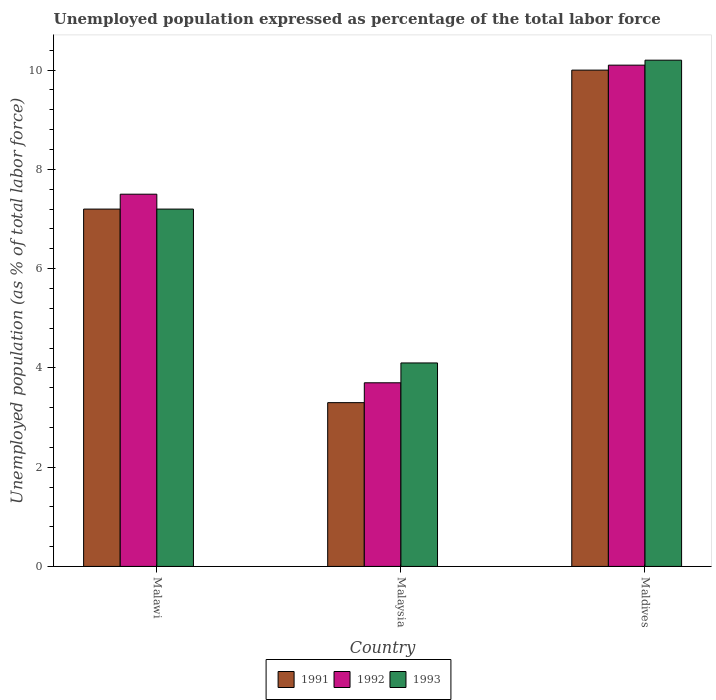How many different coloured bars are there?
Offer a terse response. 3. How many groups of bars are there?
Offer a very short reply. 3. Are the number of bars per tick equal to the number of legend labels?
Keep it short and to the point. Yes. Are the number of bars on each tick of the X-axis equal?
Your answer should be very brief. Yes. How many bars are there on the 2nd tick from the left?
Offer a very short reply. 3. How many bars are there on the 2nd tick from the right?
Your answer should be compact. 3. What is the label of the 3rd group of bars from the left?
Provide a short and direct response. Maldives. In how many cases, is the number of bars for a given country not equal to the number of legend labels?
Your answer should be compact. 0. What is the unemployment in in 1993 in Maldives?
Your answer should be very brief. 10.2. Across all countries, what is the maximum unemployment in in 1991?
Offer a terse response. 10. Across all countries, what is the minimum unemployment in in 1991?
Offer a terse response. 3.3. In which country was the unemployment in in 1992 maximum?
Ensure brevity in your answer.  Maldives. In which country was the unemployment in in 1993 minimum?
Your response must be concise. Malaysia. What is the total unemployment in in 1991 in the graph?
Offer a terse response. 20.5. What is the difference between the unemployment in in 1992 in Malawi and that in Malaysia?
Give a very brief answer. 3.8. What is the difference between the unemployment in in 1991 in Malaysia and the unemployment in in 1993 in Malawi?
Provide a short and direct response. -3.9. What is the average unemployment in in 1991 per country?
Offer a terse response. 6.83. What is the ratio of the unemployment in in 1991 in Malawi to that in Maldives?
Your answer should be compact. 0.72. Is the unemployment in in 1991 in Malawi less than that in Malaysia?
Your answer should be compact. No. Is the difference between the unemployment in in 1993 in Malawi and Malaysia greater than the difference between the unemployment in in 1991 in Malawi and Malaysia?
Provide a succinct answer. No. What is the difference between the highest and the second highest unemployment in in 1991?
Offer a terse response. 6.7. What is the difference between the highest and the lowest unemployment in in 1993?
Make the answer very short. 6.1. Is the sum of the unemployment in in 1993 in Malaysia and Maldives greater than the maximum unemployment in in 1991 across all countries?
Provide a succinct answer. Yes. What does the 2nd bar from the left in Maldives represents?
Ensure brevity in your answer.  1992. What does the 1st bar from the right in Malawi represents?
Make the answer very short. 1993. Is it the case that in every country, the sum of the unemployment in in 1992 and unemployment in in 1993 is greater than the unemployment in in 1991?
Ensure brevity in your answer.  Yes. How many bars are there?
Your answer should be very brief. 9. Are all the bars in the graph horizontal?
Offer a very short reply. No. How many countries are there in the graph?
Your response must be concise. 3. Where does the legend appear in the graph?
Give a very brief answer. Bottom center. How many legend labels are there?
Give a very brief answer. 3. What is the title of the graph?
Provide a short and direct response. Unemployed population expressed as percentage of the total labor force. Does "1960" appear as one of the legend labels in the graph?
Offer a very short reply. No. What is the label or title of the Y-axis?
Make the answer very short. Unemployed population (as % of total labor force). What is the Unemployed population (as % of total labor force) of 1991 in Malawi?
Keep it short and to the point. 7.2. What is the Unemployed population (as % of total labor force) of 1992 in Malawi?
Your answer should be compact. 7.5. What is the Unemployed population (as % of total labor force) of 1993 in Malawi?
Offer a terse response. 7.2. What is the Unemployed population (as % of total labor force) in 1991 in Malaysia?
Provide a succinct answer. 3.3. What is the Unemployed population (as % of total labor force) of 1992 in Malaysia?
Keep it short and to the point. 3.7. What is the Unemployed population (as % of total labor force) in 1993 in Malaysia?
Offer a terse response. 4.1. What is the Unemployed population (as % of total labor force) of 1991 in Maldives?
Offer a very short reply. 10. What is the Unemployed population (as % of total labor force) of 1992 in Maldives?
Your answer should be very brief. 10.1. What is the Unemployed population (as % of total labor force) in 1993 in Maldives?
Your answer should be compact. 10.2. Across all countries, what is the maximum Unemployed population (as % of total labor force) in 1992?
Provide a short and direct response. 10.1. Across all countries, what is the maximum Unemployed population (as % of total labor force) of 1993?
Ensure brevity in your answer.  10.2. Across all countries, what is the minimum Unemployed population (as % of total labor force) in 1991?
Provide a short and direct response. 3.3. Across all countries, what is the minimum Unemployed population (as % of total labor force) of 1992?
Give a very brief answer. 3.7. Across all countries, what is the minimum Unemployed population (as % of total labor force) of 1993?
Your response must be concise. 4.1. What is the total Unemployed population (as % of total labor force) of 1991 in the graph?
Give a very brief answer. 20.5. What is the total Unemployed population (as % of total labor force) in 1992 in the graph?
Provide a short and direct response. 21.3. What is the difference between the Unemployed population (as % of total labor force) of 1991 in Malawi and that in Malaysia?
Give a very brief answer. 3.9. What is the difference between the Unemployed population (as % of total labor force) in 1992 in Malawi and that in Malaysia?
Your answer should be very brief. 3.8. What is the difference between the Unemployed population (as % of total labor force) in 1993 in Malawi and that in Malaysia?
Your answer should be compact. 3.1. What is the difference between the Unemployed population (as % of total labor force) in 1992 in Malawi and that in Maldives?
Provide a short and direct response. -2.6. What is the difference between the Unemployed population (as % of total labor force) in 1993 in Malawi and that in Maldives?
Give a very brief answer. -3. What is the difference between the Unemployed population (as % of total labor force) in 1992 in Malaysia and that in Maldives?
Offer a terse response. -6.4. What is the difference between the Unemployed population (as % of total labor force) of 1993 in Malaysia and that in Maldives?
Your answer should be very brief. -6.1. What is the difference between the Unemployed population (as % of total labor force) of 1992 in Malawi and the Unemployed population (as % of total labor force) of 1993 in Malaysia?
Make the answer very short. 3.4. What is the difference between the Unemployed population (as % of total labor force) of 1991 in Malawi and the Unemployed population (as % of total labor force) of 1993 in Maldives?
Ensure brevity in your answer.  -3. What is the difference between the Unemployed population (as % of total labor force) in 1991 in Malaysia and the Unemployed population (as % of total labor force) in 1992 in Maldives?
Give a very brief answer. -6.8. What is the average Unemployed population (as % of total labor force) in 1991 per country?
Offer a very short reply. 6.83. What is the average Unemployed population (as % of total labor force) in 1992 per country?
Offer a very short reply. 7.1. What is the average Unemployed population (as % of total labor force) of 1993 per country?
Offer a very short reply. 7.17. What is the difference between the Unemployed population (as % of total labor force) in 1991 and Unemployed population (as % of total labor force) in 1992 in Malawi?
Offer a terse response. -0.3. What is the difference between the Unemployed population (as % of total labor force) of 1991 and Unemployed population (as % of total labor force) of 1993 in Malawi?
Ensure brevity in your answer.  0. What is the difference between the Unemployed population (as % of total labor force) of 1991 and Unemployed population (as % of total labor force) of 1992 in Malaysia?
Your answer should be very brief. -0.4. What is the difference between the Unemployed population (as % of total labor force) in 1992 and Unemployed population (as % of total labor force) in 1993 in Malaysia?
Offer a terse response. -0.4. What is the ratio of the Unemployed population (as % of total labor force) of 1991 in Malawi to that in Malaysia?
Offer a terse response. 2.18. What is the ratio of the Unemployed population (as % of total labor force) of 1992 in Malawi to that in Malaysia?
Your answer should be very brief. 2.03. What is the ratio of the Unemployed population (as % of total labor force) in 1993 in Malawi to that in Malaysia?
Provide a short and direct response. 1.76. What is the ratio of the Unemployed population (as % of total labor force) in 1991 in Malawi to that in Maldives?
Provide a succinct answer. 0.72. What is the ratio of the Unemployed population (as % of total labor force) in 1992 in Malawi to that in Maldives?
Your answer should be compact. 0.74. What is the ratio of the Unemployed population (as % of total labor force) of 1993 in Malawi to that in Maldives?
Offer a very short reply. 0.71. What is the ratio of the Unemployed population (as % of total labor force) in 1991 in Malaysia to that in Maldives?
Ensure brevity in your answer.  0.33. What is the ratio of the Unemployed population (as % of total labor force) of 1992 in Malaysia to that in Maldives?
Give a very brief answer. 0.37. What is the ratio of the Unemployed population (as % of total labor force) in 1993 in Malaysia to that in Maldives?
Provide a succinct answer. 0.4. What is the difference between the highest and the second highest Unemployed population (as % of total labor force) in 1991?
Your answer should be compact. 2.8. What is the difference between the highest and the lowest Unemployed population (as % of total labor force) of 1992?
Provide a succinct answer. 6.4. 